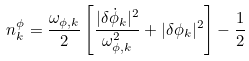Convert formula to latex. <formula><loc_0><loc_0><loc_500><loc_500>n _ { k } ^ { \phi } = \frac { \omega _ { \phi , k } } { 2 } \left [ \frac { | \delta \dot { \phi } _ { k } | ^ { 2 } } { \omega _ { \phi , k } ^ { 2 } } + | \delta \phi _ { k } | ^ { 2 } \right ] - \frac { 1 } { 2 }</formula> 